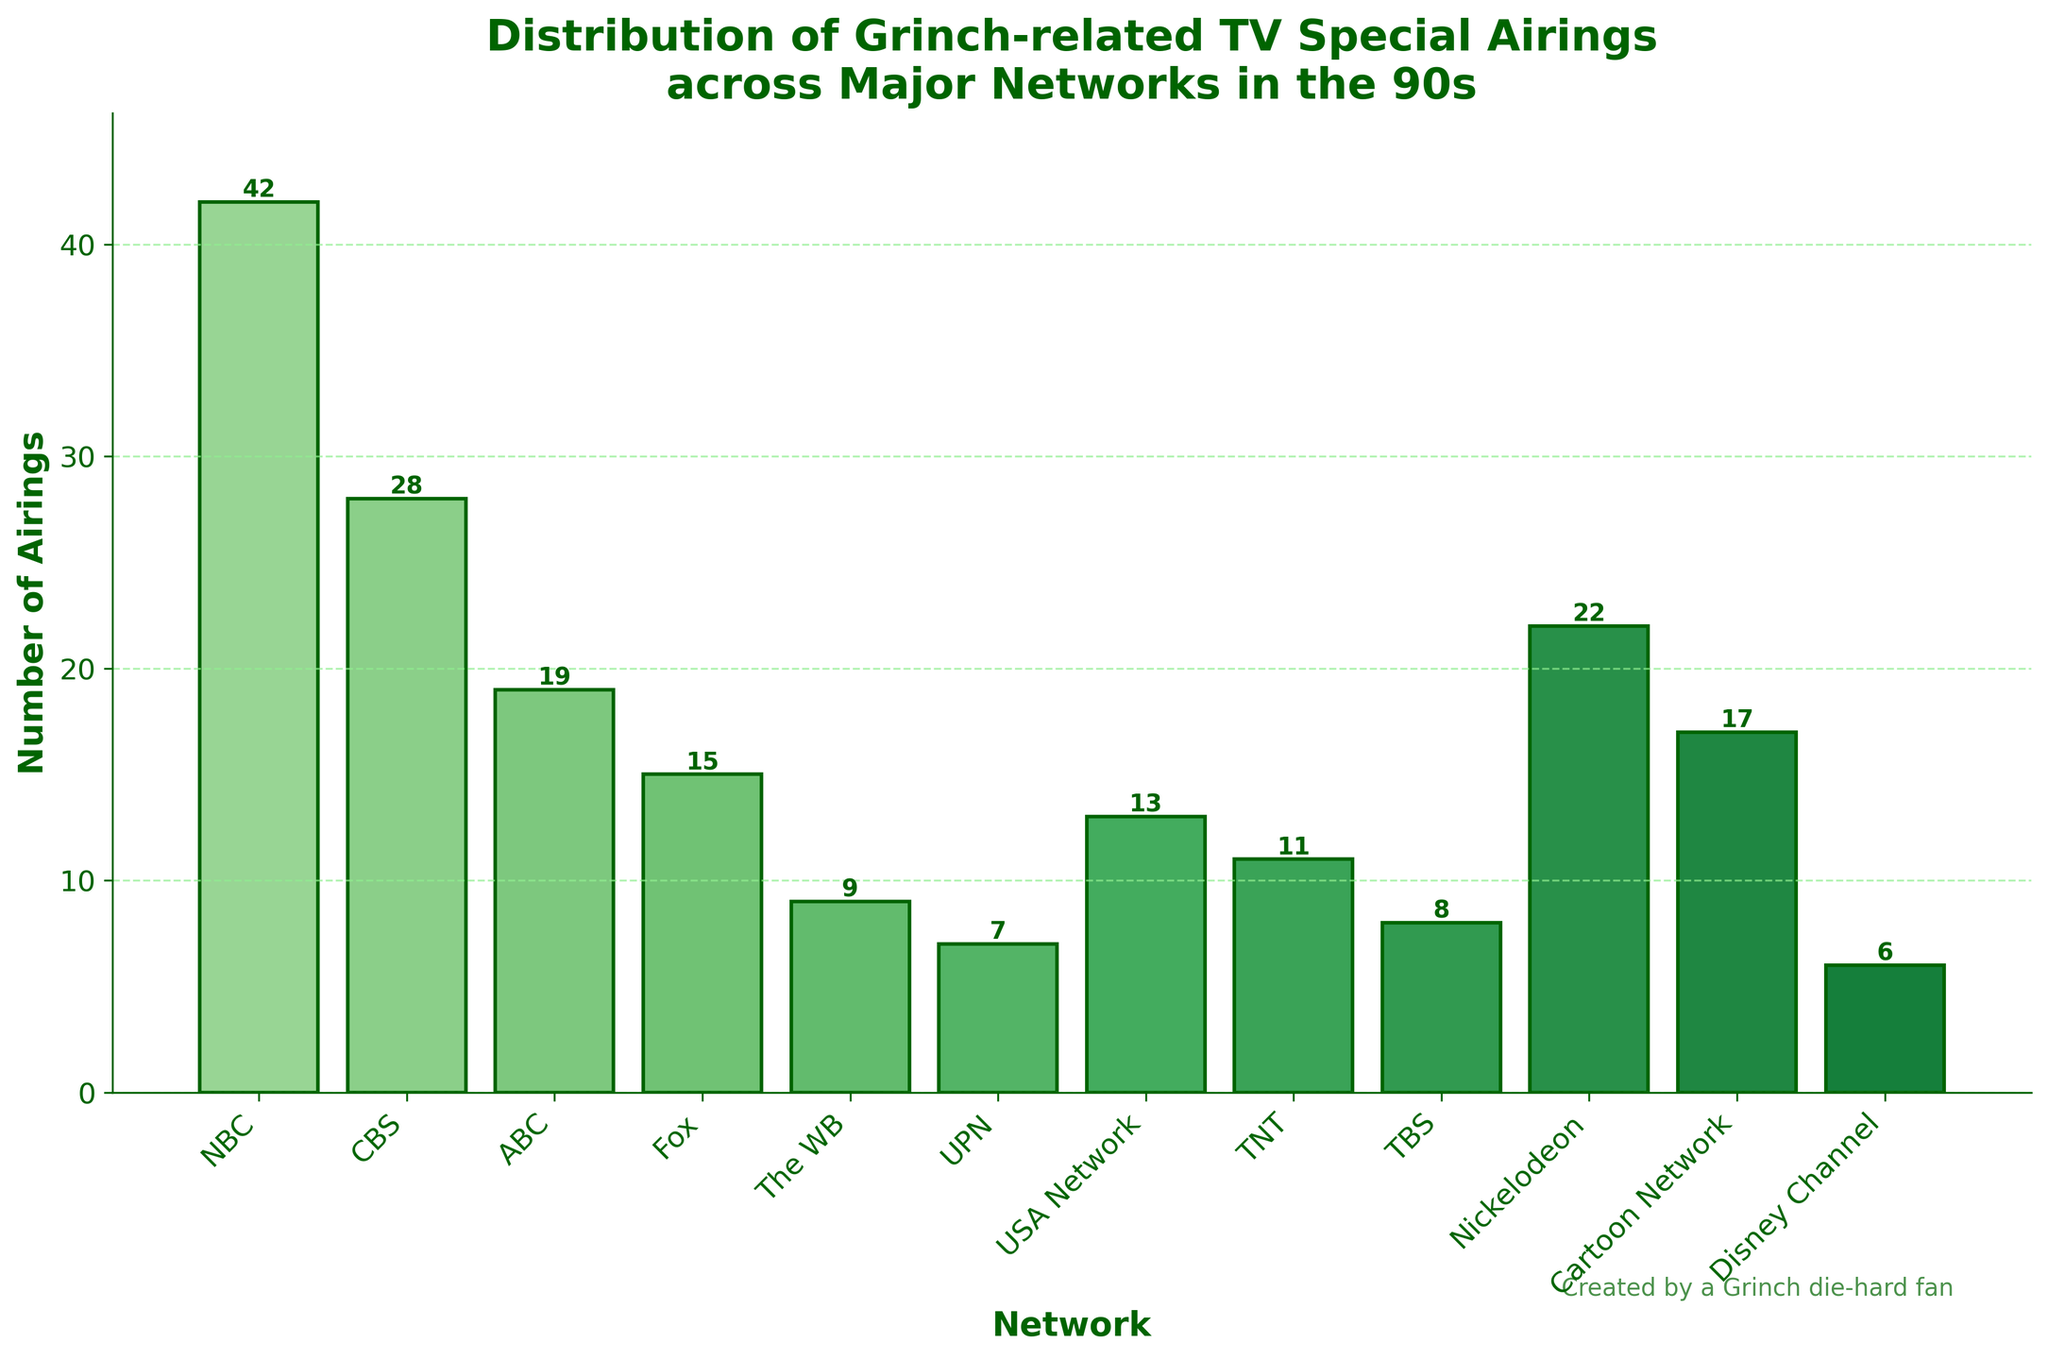Which network had the highest number of Grinch-related TV special airings? Look for the bar that is the tallest in the figure, corresponding to the number of airings and the network.
Answer: NBC Which network had the lowest number of Grinch-related TV special airings? Identify the shortest bar in the figure and its associated label.
Answer: Disney Channel What is the total number of airings on major networks? Sum the values of all the bars in the figure: 42 + 28 + 19 + 15 + 9 + 7 + 13 + 11 + 8 + 22 + 17 + 6 = 197.
Answer: 197 How many more airings did NBC have compared to ABC? Identify the number of airings for NBC (42) and ABC (19), and subtract ABC from NBC: 42 - 19 = 23.
Answer: 23 What is the average number of airings across all networks? Sum the values and divide by the total number of networks: (42 + 28 + 19 + 15 + 9 + 7 + 13 + 11 + 8 + 22 + 17 + 6) / 12 = 16.42.
Answer: 16.42 Which network had more airings, Fox or Nickelodeon? Identify the number of airings for Fox (15) and Nickelodeon (22), and compare: 22 is more than 15.
Answer: Nickelodeon By how much did Nickelodeon exceed the average number of airings? Calculate the difference between Nickelodeon’s airings (22) and the average airings (16.42): 22 - 16.42 = 5.58.
Answer: 5.58 What combined share of total airings did NBC and CBS have? Sum the airings of NBC (42) and CBS (28) and calculate their percentage of the total airings (197): (42 + 28) / 197 ≈ 0.355 or 35.5%.
Answer: 35.5% How many networks had fewer airings than TNT? List the networks with fewer airings than TNT (11): The WB (9), UPN (7), TBS (8), Disney Channel (6) – total 4 networks.
Answer: 4 Which network between USA Network and Cartoon Network aired Grinch-related specials more frequently? Compare the airings: USA Network has 13 and Cartoon Network has 17.
Answer: Cartoon Network 